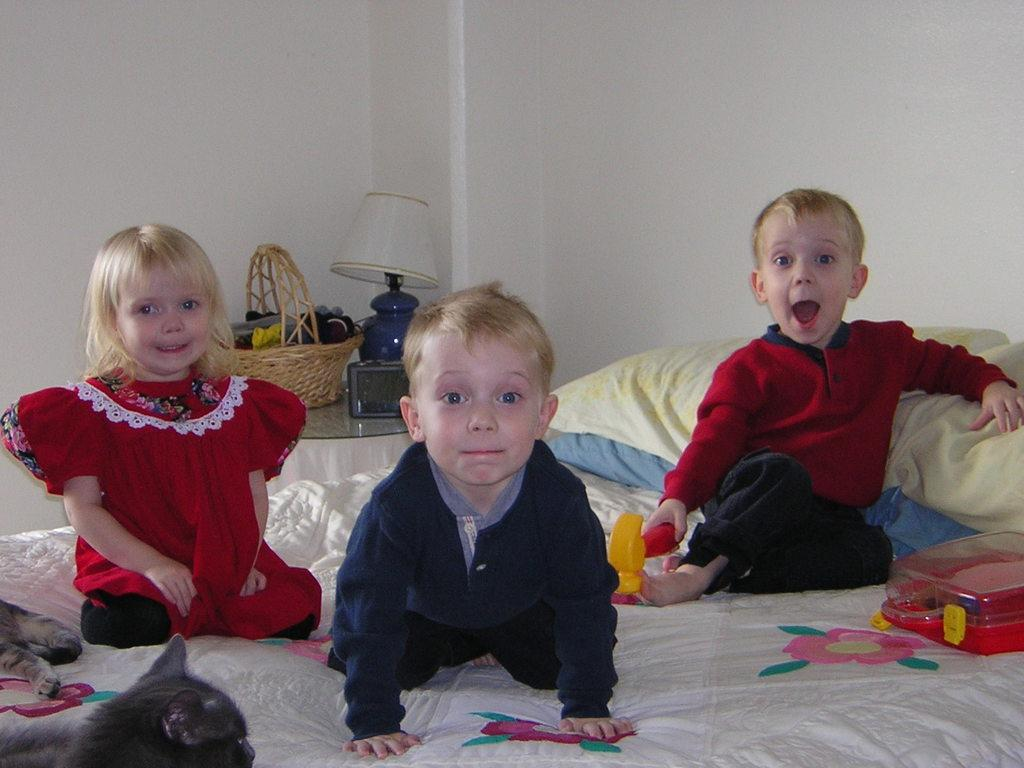What are the kids doing in the image? The kids are on the bed in the image. What animals can be seen in the image? There are cats in the bottom left corner of the image. What objects are visible in the background of the image? There is a basket, a light, pillows, and a wall in the background of the image. What type of force is being applied to the plate in the image? There is no plate present in the image, so it is not possible to determine if any force is being applied to it. 